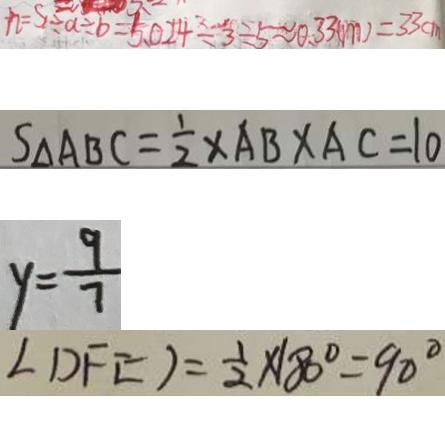Convert formula to latex. <formula><loc_0><loc_0><loc_500><loc_500>h = S \div a \div b = 5 . 0 2 4 \div 3 \div 5 \approx 0 . 3 3 ( m ) = 3 3 c m 
 S _ { \Delta } A B C = \frac { 1 } { 2 } \times A B \times A C = 1 0 
 y = \frac { 9 } { 7 } 
 \angle D F E ) = \frac { 1 } { 2 } \times 1 8 0 ^ { \circ } = 9 0 ^ { \circ }</formula> 